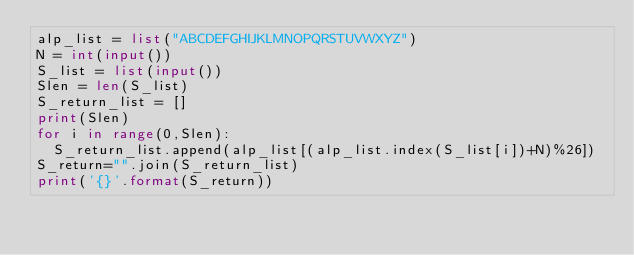<code> <loc_0><loc_0><loc_500><loc_500><_Python_>alp_list = list("ABCDEFGHIJKLMNOPQRSTUVWXYZ")
N = int(input())
S_list = list(input())
Slen = len(S_list)
S_return_list = []
print(Slen)
for i in range(0,Slen):
  S_return_list.append(alp_list[(alp_list.index(S_list[i])+N)%26])
S_return="".join(S_return_list)
print('{}'.format(S_return))</code> 